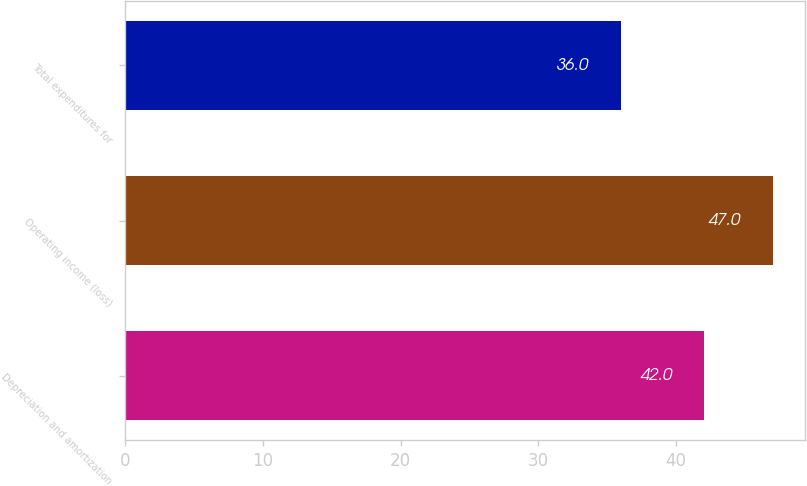Convert chart to OTSL. <chart><loc_0><loc_0><loc_500><loc_500><bar_chart><fcel>Depreciation and amortization<fcel>Operating income (loss)<fcel>Total expenditures for<nl><fcel>42<fcel>47<fcel>36<nl></chart> 